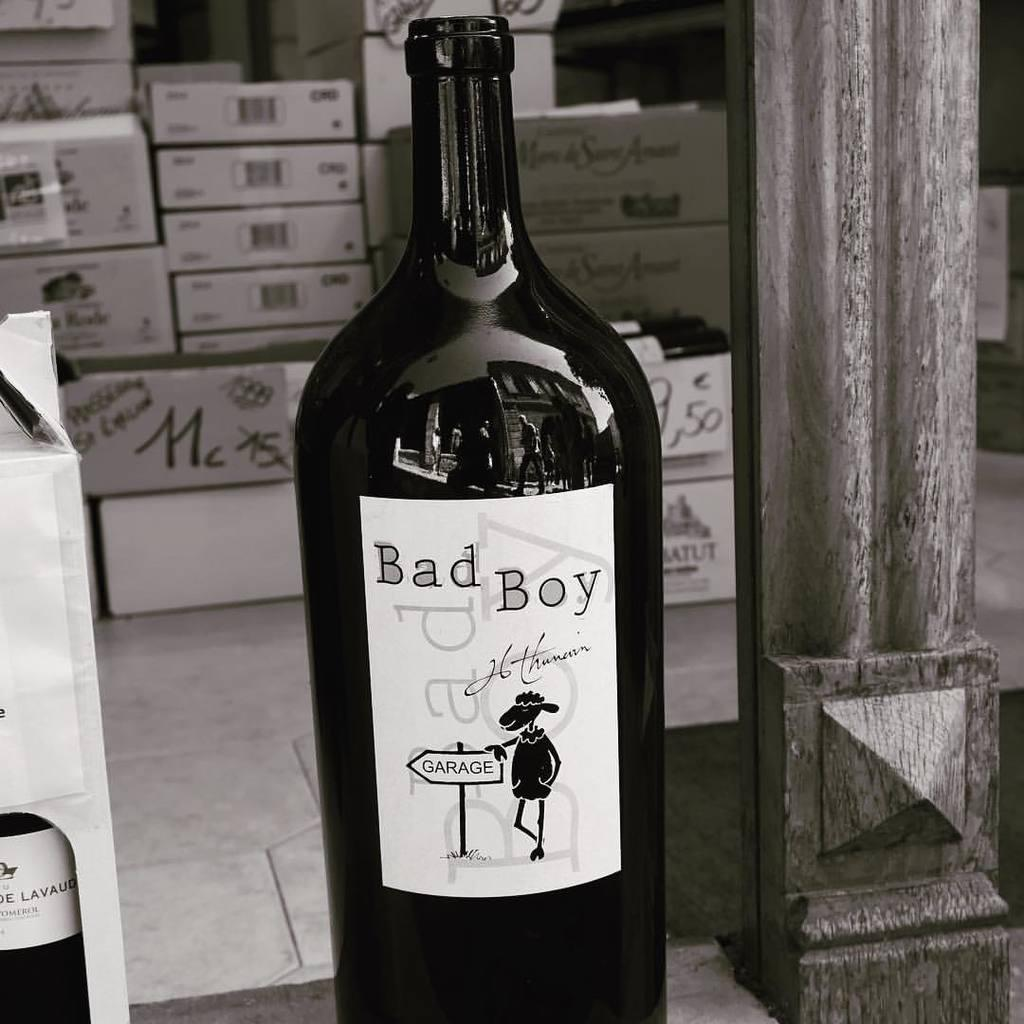<image>
Summarize the visual content of the image. A bottle of Bad Boy sits next to a box of some other type of beverage. 